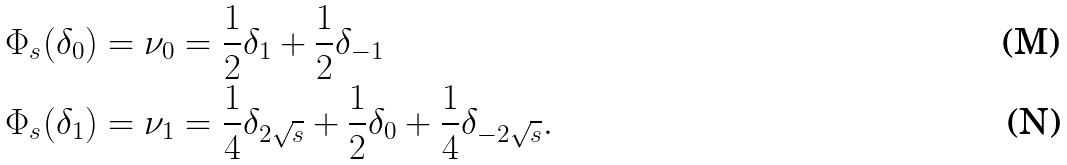Convert formula to latex. <formula><loc_0><loc_0><loc_500><loc_500>\Phi _ { s } ( \delta _ { 0 } ) = \nu _ { 0 } & = \frac { 1 } { 2 } \delta _ { 1 } + \frac { 1 } { 2 } \delta _ { - 1 } \\ \Phi _ { s } ( \delta _ { 1 } ) = \nu _ { 1 } & = \frac { 1 } { 4 } \delta _ { 2 \sqrt { s } } + \frac { 1 } { 2 } \delta _ { 0 } + \frac { 1 } { 4 } \delta _ { - 2 \sqrt { s } } .</formula> 